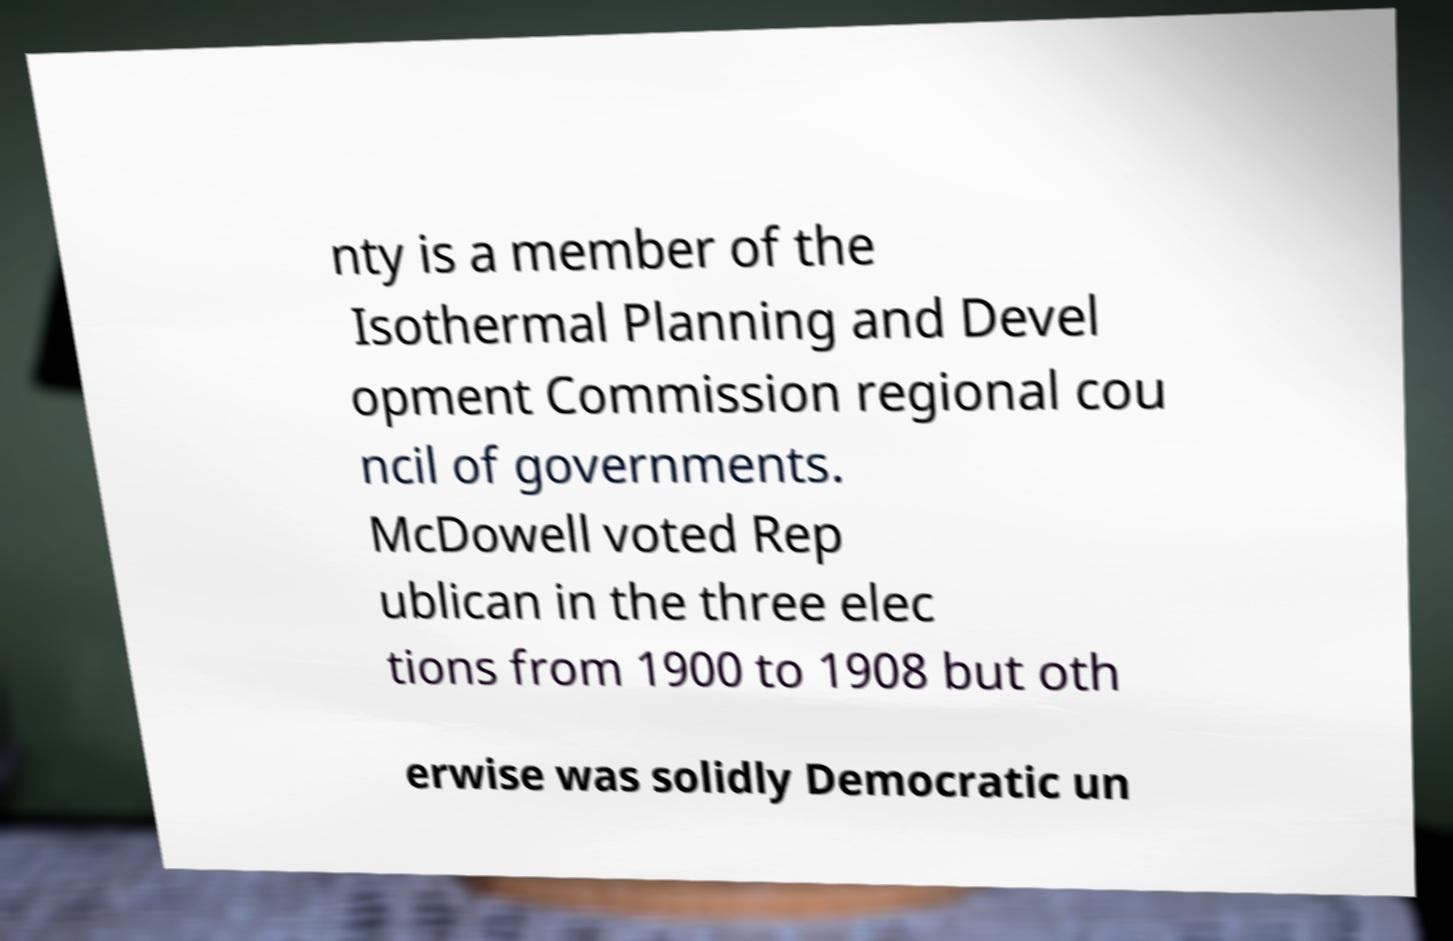I need the written content from this picture converted into text. Can you do that? nty is a member of the Isothermal Planning and Devel opment Commission regional cou ncil of governments. McDowell voted Rep ublican in the three elec tions from 1900 to 1908 but oth erwise was solidly Democratic un 